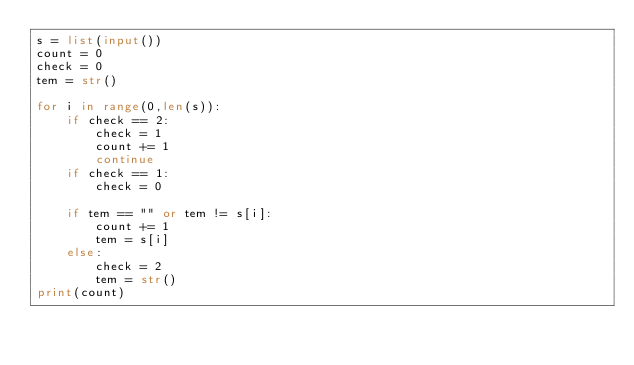<code> <loc_0><loc_0><loc_500><loc_500><_Python_>s = list(input())
count = 0
check = 0
tem = str()

for i in range(0,len(s)):
    if check == 2:
        check = 1
        count += 1
        continue
    if check == 1:
        check = 0

    if tem == "" or tem != s[i]:
        count += 1
        tem = s[i]
    else:
        check = 2
        tem = str()
print(count)</code> 